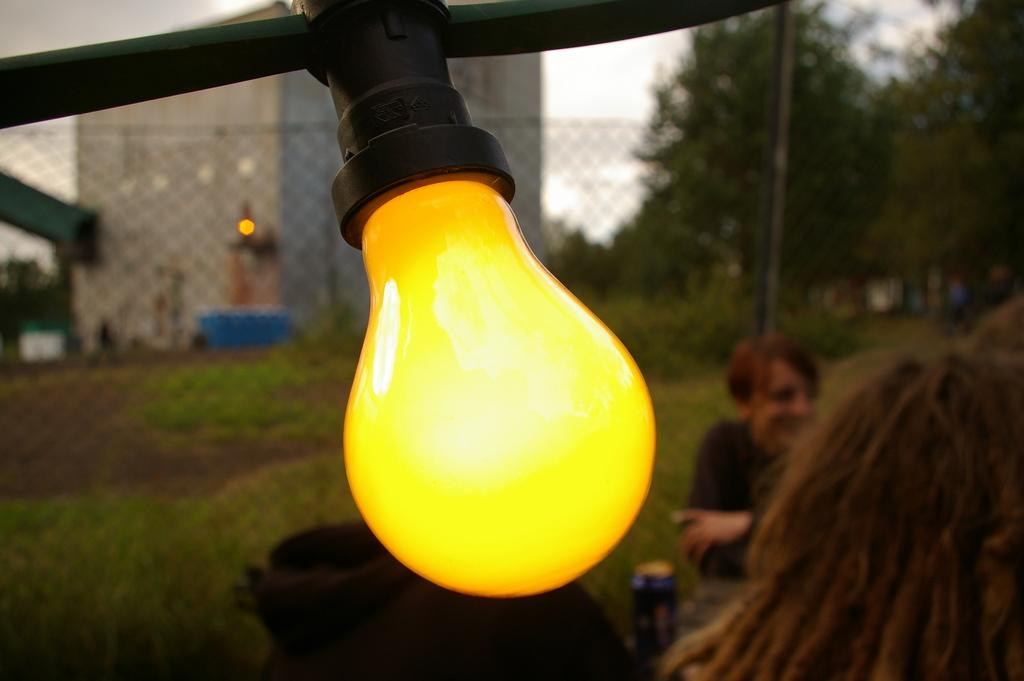What object can be seen hanging from the ceiling in the image? There is a light bulb in the image. What are the people in the image doing? The people in the image are sitting. What type of barrier is present in the image? There is a fence in the image. What type of vegetation is visible in the image? There are trees in the image. What type of structure is present in the image? There is a building in the image. What is visible in the sky in the image? The sky is visible in the image. How many cushions are being used by the person sitting on the fence in the image? There is no person sitting on the fence in the image, and therefore no cushions are present. What type of brother is depicted in the image? There is no brother depicted in the image. 